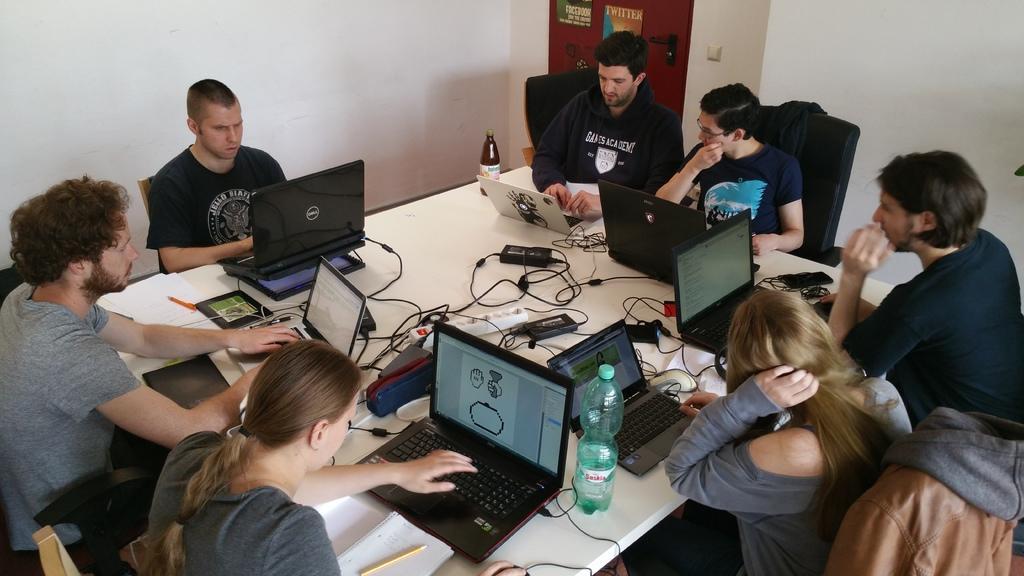Could you give a brief overview of what you see in this image? In this picture we can see a group of people sitting on chairs and on the cars there are jackets. In front of the people there is a table and on the table there are laptops, bottles, power adapters, cables, books, pens and some objects. Behind the people there is a wall with a door. 